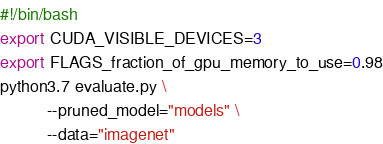Convert code to text. <code><loc_0><loc_0><loc_500><loc_500><_Bash_>#!/bin/bash  
export CUDA_VISIBLE_DEVICES=3
export FLAGS_fraction_of_gpu_memory_to_use=0.98
python3.7 evaluate.py \
          --pruned_model="models" \
          --data="imagenet"
</code> 